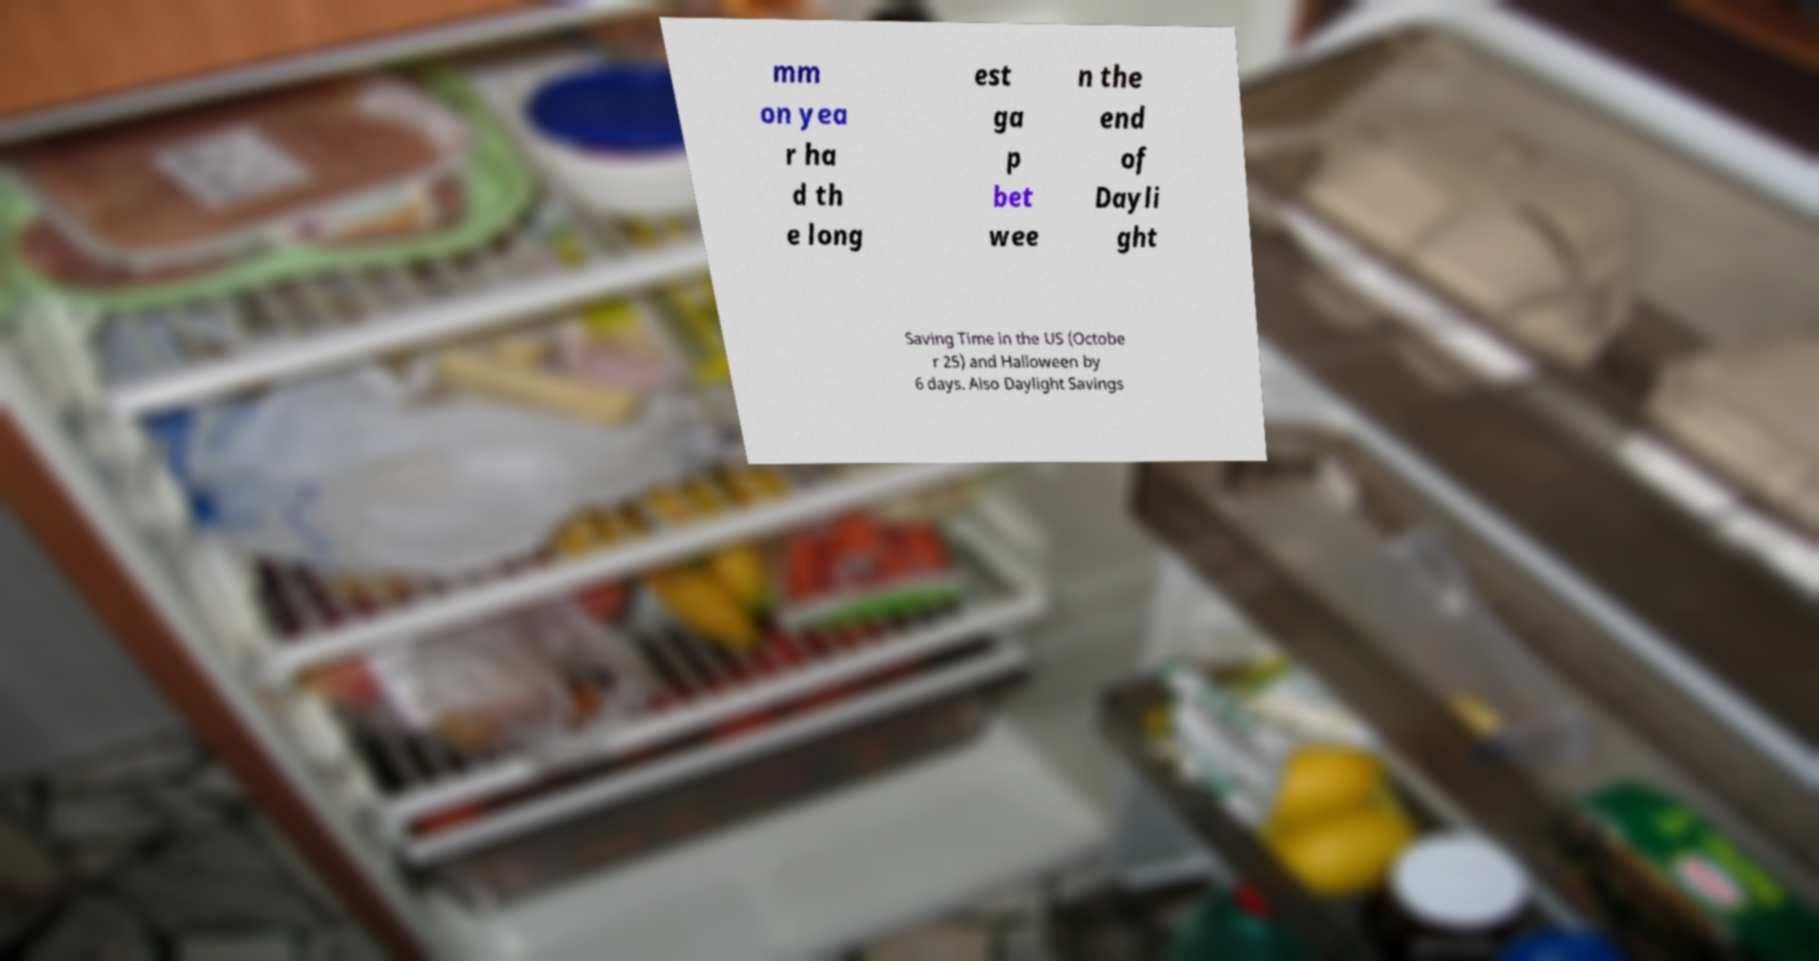What messages or text are displayed in this image? I need them in a readable, typed format. mm on yea r ha d th e long est ga p bet wee n the end of Dayli ght Saving Time in the US (Octobe r 25) and Halloween by 6 days. Also Daylight Savings 